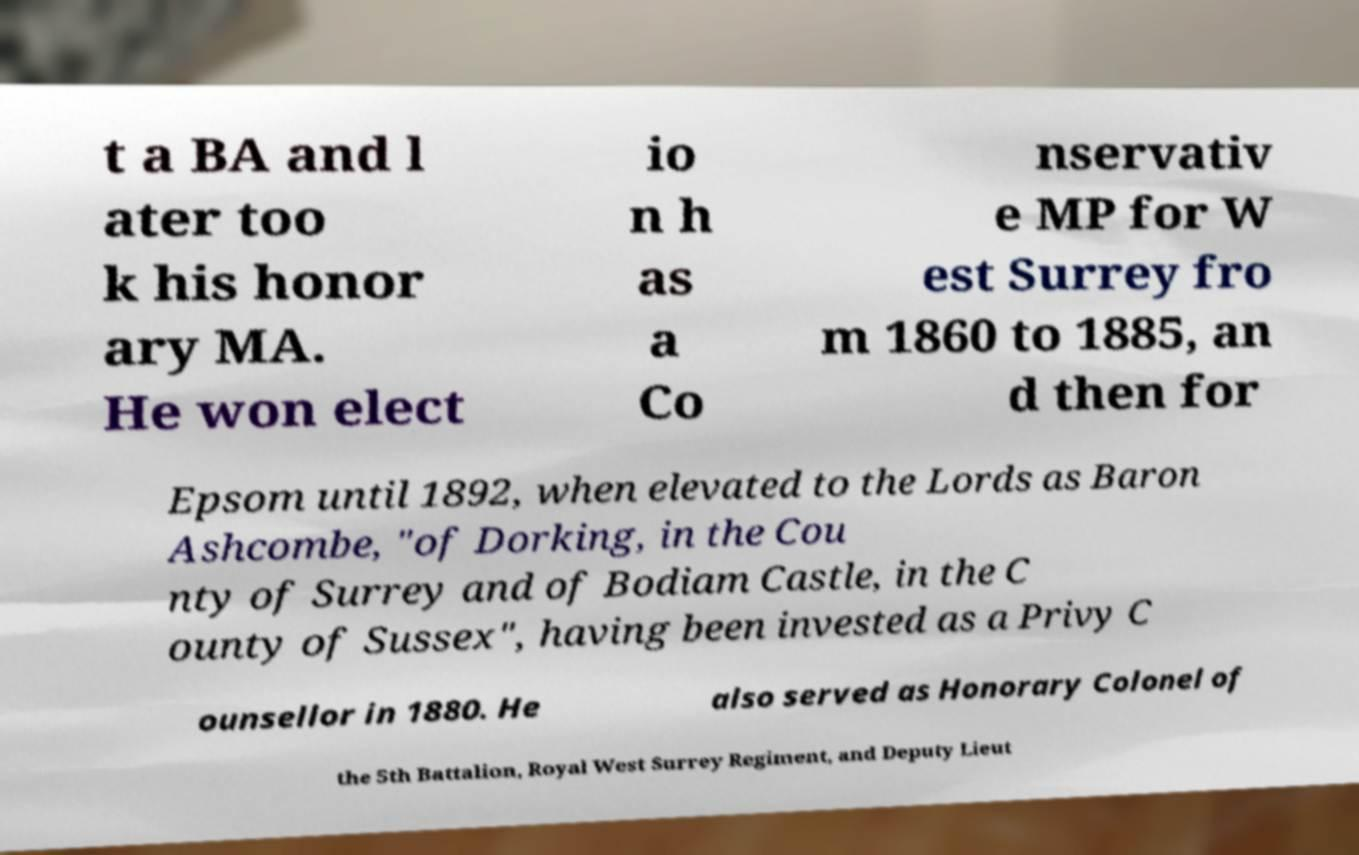What messages or text are displayed in this image? I need them in a readable, typed format. t a BA and l ater too k his honor ary MA. He won elect io n h as a Co nservativ e MP for W est Surrey fro m 1860 to 1885, an d then for Epsom until 1892, when elevated to the Lords as Baron Ashcombe, "of Dorking, in the Cou nty of Surrey and of Bodiam Castle, in the C ounty of Sussex", having been invested as a Privy C ounsellor in 1880. He also served as Honorary Colonel of the 5th Battalion, Royal West Surrey Regiment, and Deputy Lieut 